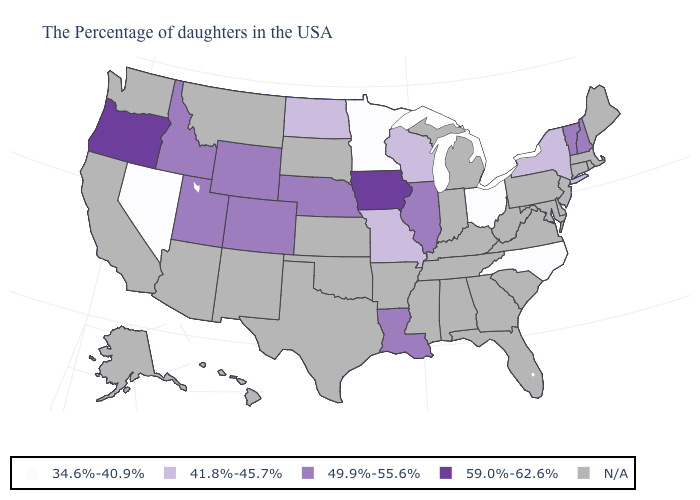What is the highest value in the USA?
Quick response, please. 59.0%-62.6%. Is the legend a continuous bar?
Short answer required. No. Name the states that have a value in the range 41.8%-45.7%?
Write a very short answer. New York, Wisconsin, Missouri, North Dakota. Among the states that border Nevada , does Utah have the highest value?
Keep it brief. No. Among the states that border Utah , which have the lowest value?
Answer briefly. Nevada. Name the states that have a value in the range 59.0%-62.6%?
Give a very brief answer. Iowa, Oregon. Among the states that border Indiana , does Ohio have the lowest value?
Write a very short answer. Yes. What is the highest value in states that border Oklahoma?
Keep it brief. 49.9%-55.6%. What is the value of Rhode Island?
Write a very short answer. N/A. Name the states that have a value in the range N/A?
Give a very brief answer. Maine, Massachusetts, Rhode Island, Connecticut, New Jersey, Delaware, Maryland, Pennsylvania, Virginia, South Carolina, West Virginia, Florida, Georgia, Michigan, Kentucky, Indiana, Alabama, Tennessee, Mississippi, Arkansas, Kansas, Oklahoma, Texas, South Dakota, New Mexico, Montana, Arizona, California, Washington, Alaska, Hawaii. Among the states that border Indiana , does Ohio have the highest value?
Short answer required. No. Does the first symbol in the legend represent the smallest category?
Write a very short answer. Yes. Does Oregon have the highest value in the USA?
Answer briefly. Yes. 